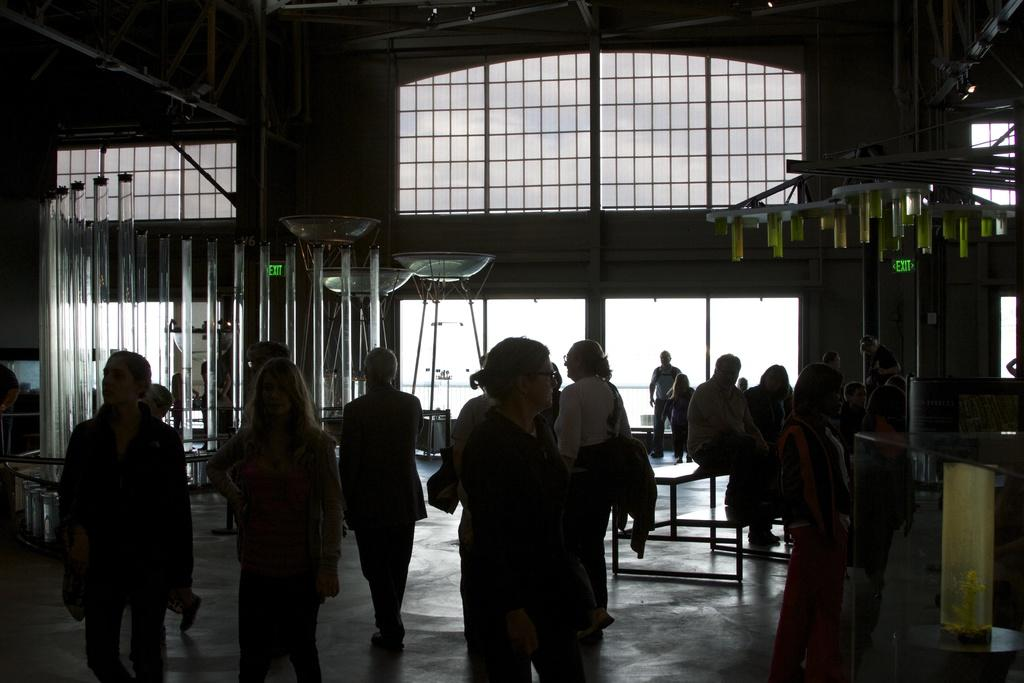What are the people in the image doing? There are people standing on the floor and sitting on benches in the image. What can be seen in the background of the image? There are walls, windows, and glass containers in the background of the image. How is the brain being distributed among the people in the image? There is no mention of a brain or its distribution in the image. 